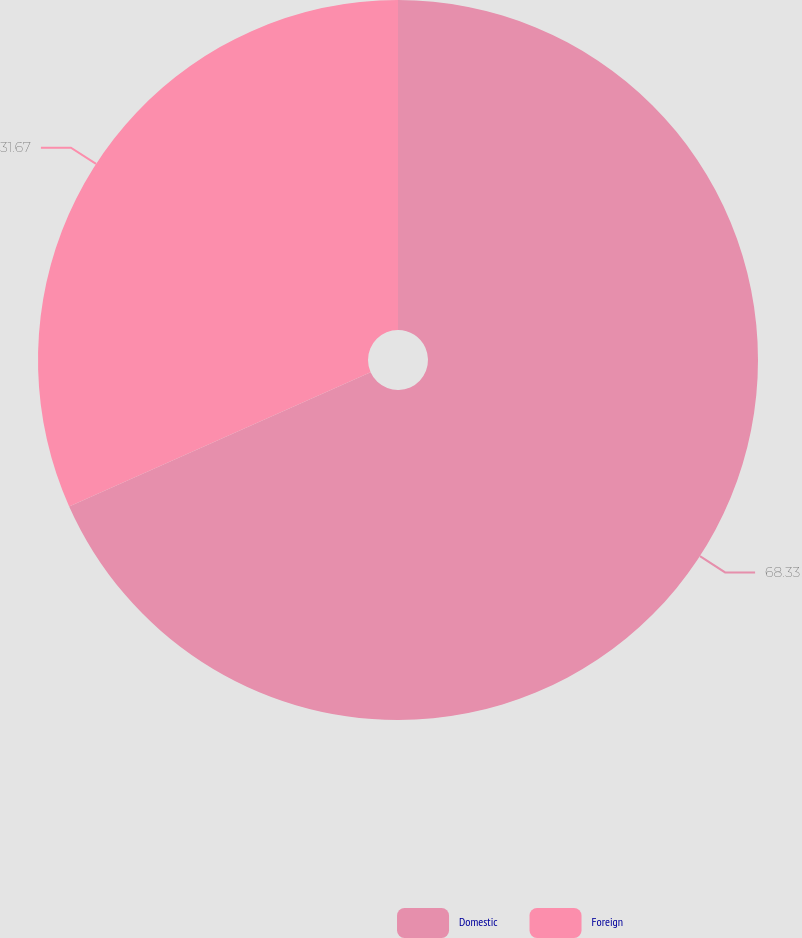<chart> <loc_0><loc_0><loc_500><loc_500><pie_chart><fcel>Domestic<fcel>Foreign<nl><fcel>68.33%<fcel>31.67%<nl></chart> 